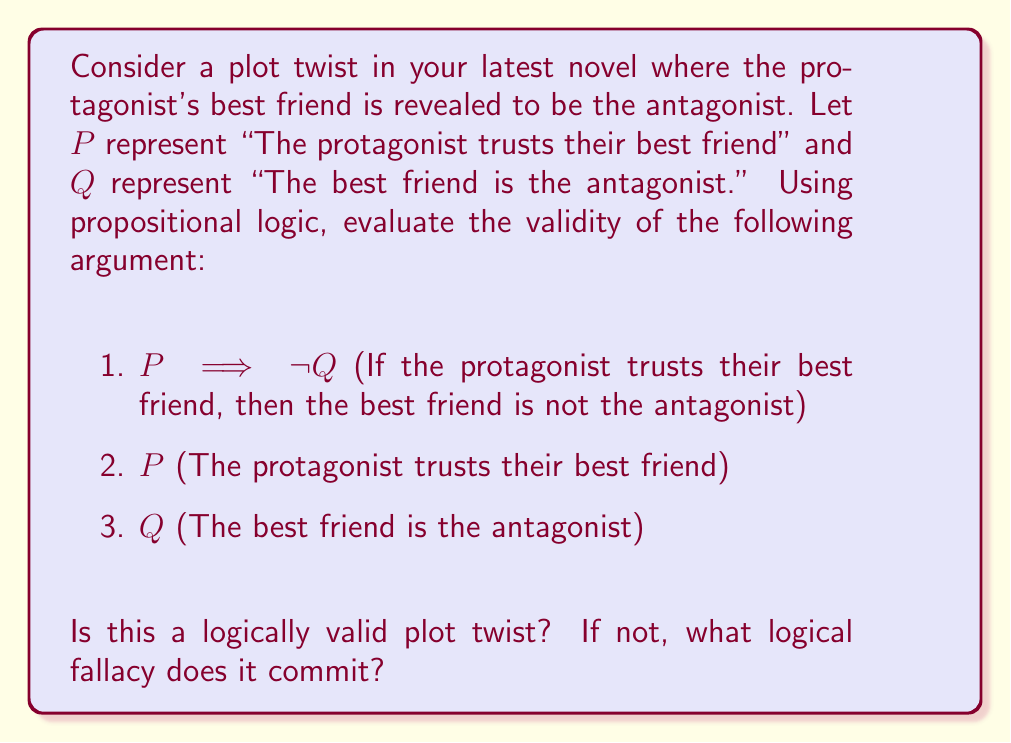Provide a solution to this math problem. To evaluate the logical validity of this plot twist, we need to examine the given premises and conclusion using propositional logic and inference rules.

Let's break down the argument:

1. $P \implies \neg Q$ (Premise)
2. $P$ (Premise)
3. $Q$ (Conclusion)

To check for validity, we can use the method of proof by contradiction. We'll assume the premises are true and see if we can derive a contradiction with the conclusion.

Step 1: Apply Modus Ponens to premises 1 and 2
$P \implies \neg Q$ (Premise 1)
$P$ (Premise 2)
Therefore, $\neg Q$ (Modus Ponens)

Step 2: Compare the result with the conclusion
We derived $\neg Q$, but the conclusion states $Q$.

This is a direct contradiction. In propositional logic, a statement and its negation cannot both be true simultaneously.

The plot twist, as presented, is not logically valid. It commits the logical fallacy known as "contradiction" or "inconsistency."

In terms of character development and plot building, this inconsistency could be intentional to create dramatic tension or surprise. However, from a purely logical standpoint, it's invalid.

To make the plot twist logically valid, one could:
1. Change premise 1 to $P \implies Q$ (If the protagonist trusts their best friend, then the best friend is the antagonist)
2. Remove premise 2 ($P$) and use premise 1 with the conclusion $Q$ to infer $P$ through Modus Ponens
3. Keep premises 1 and 2, but change the conclusion to $\neg Q$, which would make a valid argument but wouldn't support the desired plot twist
Answer: The plot twist is not logically valid. It commits the logical fallacy of contradiction or inconsistency. 